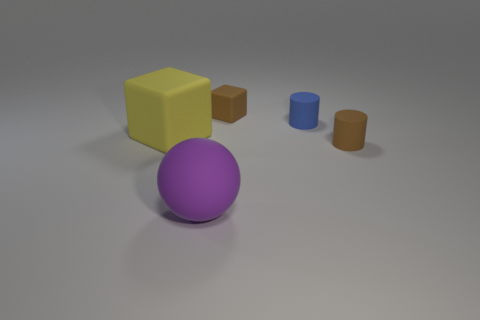Subtract all gray spheres. Subtract all blue cylinders. How many spheres are left? 1 Add 4 small red cubes. How many objects exist? 9 Subtract all spheres. How many objects are left? 4 Subtract all small blue rubber objects. Subtract all brown matte cubes. How many objects are left? 3 Add 5 blue rubber things. How many blue rubber things are left? 6 Add 5 green things. How many green things exist? 5 Subtract 0 gray spheres. How many objects are left? 5 